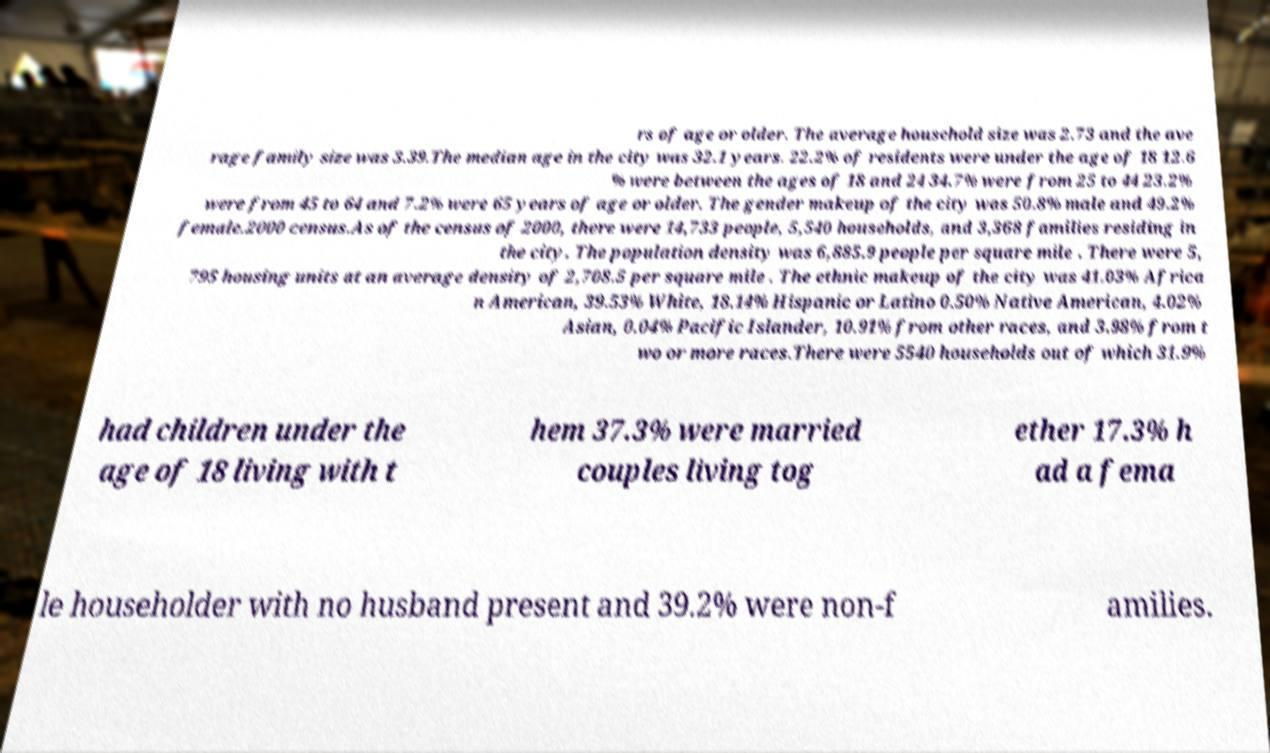Can you read and provide the text displayed in the image?This photo seems to have some interesting text. Can you extract and type it out for me? rs of age or older. The average household size was 2.73 and the ave rage family size was 3.39.The median age in the city was 32.1 years. 22.2% of residents were under the age of 18 12.6 % were between the ages of 18 and 24 34.7% were from 25 to 44 23.2% were from 45 to 64 and 7.2% were 65 years of age or older. The gender makeup of the city was 50.8% male and 49.2% female.2000 census.As of the census of 2000, there were 14,733 people, 5,540 households, and 3,368 families residing in the city. The population density was 6,885.9 people per square mile . There were 5, 795 housing units at an average density of 2,708.5 per square mile . The ethnic makeup of the city was 41.03% Africa n American, 39.53% White, 18.14% Hispanic or Latino 0.50% Native American, 4.02% Asian, 0.04% Pacific Islander, 10.91% from other races, and 3.98% from t wo or more races.There were 5540 households out of which 31.9% had children under the age of 18 living with t hem 37.3% were married couples living tog ether 17.3% h ad a fema le householder with no husband present and 39.2% were non-f amilies. 